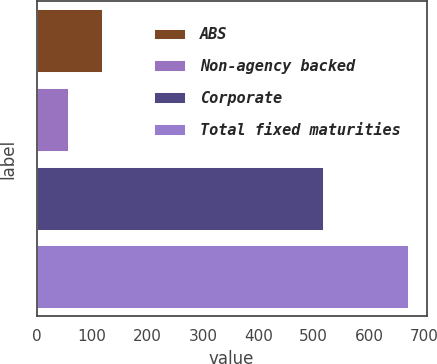Convert chart to OTSL. <chart><loc_0><loc_0><loc_500><loc_500><bar_chart><fcel>ABS<fcel>Non-agency backed<fcel>Corporate<fcel>Total fixed maturities<nl><fcel>118.3<fcel>57<fcel>517<fcel>670<nl></chart> 